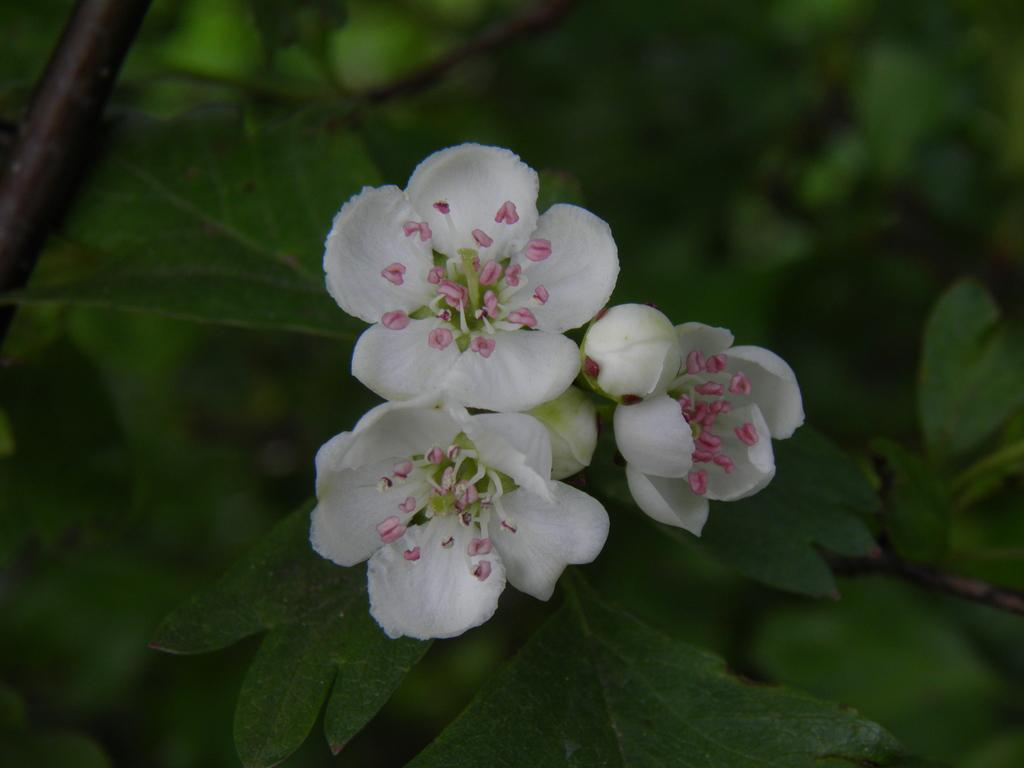What color can be seen on the plant in the image? There are white colors on the plant. What stage of growth can be observed on the plant? There are buds on the plant. What type of scarf can be seen wrapped around the plant in the image? There is no scarf present wrapped around the plant in the image. Can you read any notes attached to the plant in the image? There is no note present attached to the plant in the image. 